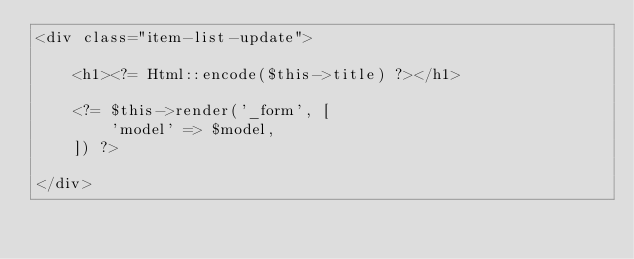Convert code to text. <code><loc_0><loc_0><loc_500><loc_500><_PHP_><div class="item-list-update">

    <h1><?= Html::encode($this->title) ?></h1>

    <?= $this->render('_form', [
        'model' => $model,
    ]) ?>

</div>
</code> 